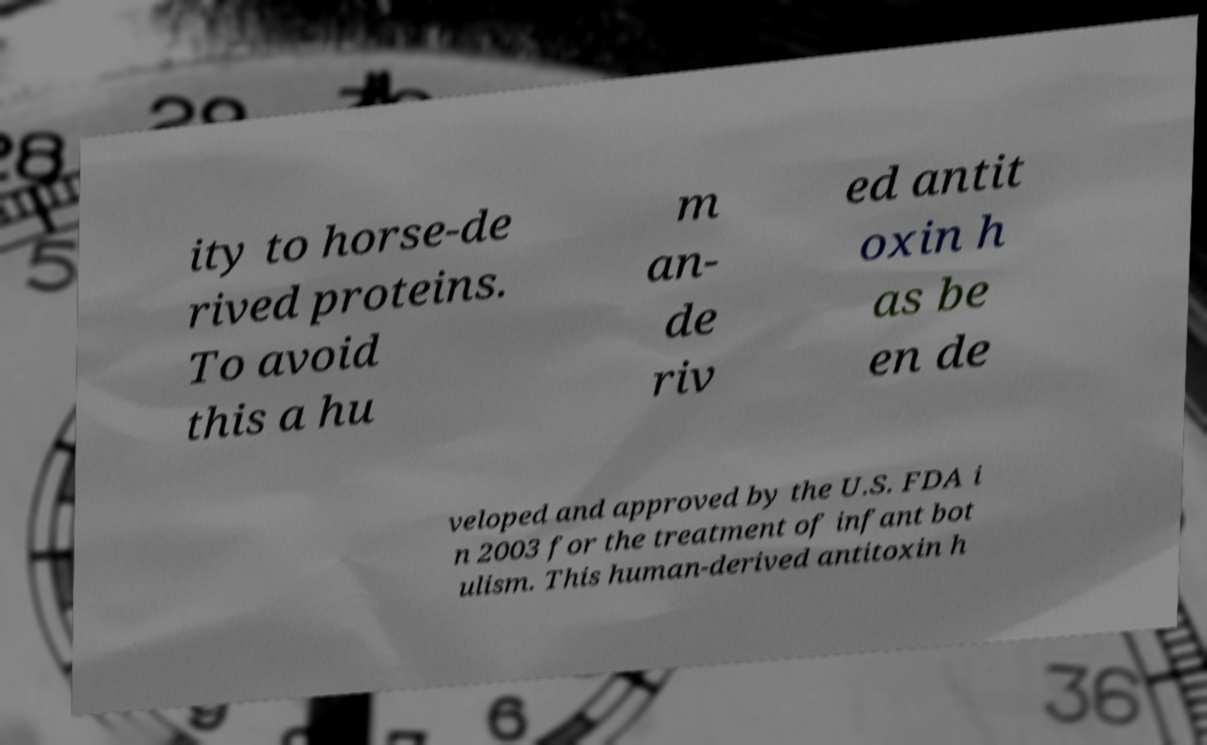What messages or text are displayed in this image? I need them in a readable, typed format. ity to horse-de rived proteins. To avoid this a hu m an- de riv ed antit oxin h as be en de veloped and approved by the U.S. FDA i n 2003 for the treatment of infant bot ulism. This human-derived antitoxin h 